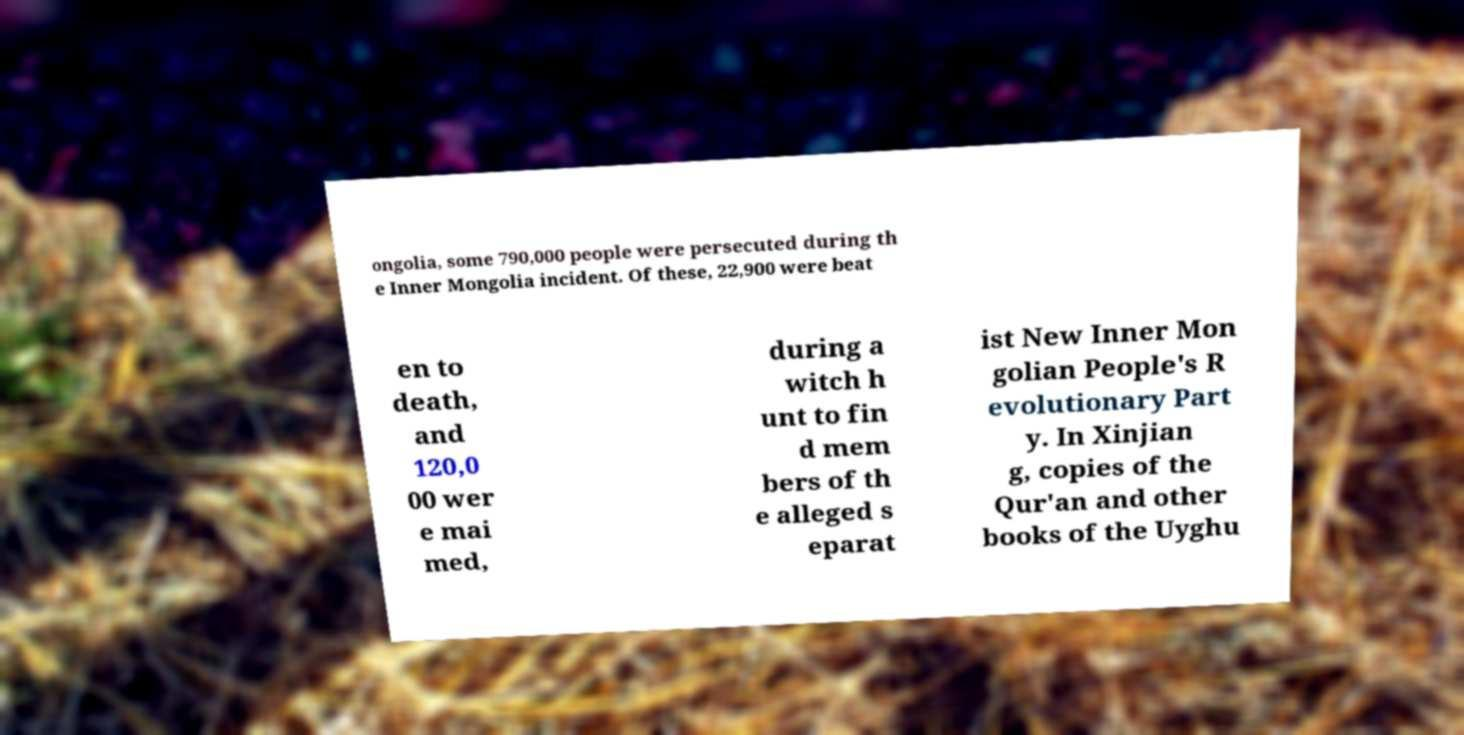Can you accurately transcribe the text from the provided image for me? ongolia, some 790,000 people were persecuted during th e Inner Mongolia incident. Of these, 22,900 were beat en to death, and 120,0 00 wer e mai med, during a witch h unt to fin d mem bers of th e alleged s eparat ist New Inner Mon golian People's R evolutionary Part y. In Xinjian g, copies of the Qur'an and other books of the Uyghu 